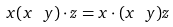<formula> <loc_0><loc_0><loc_500><loc_500>x ( x \ y ) \cdot z = x \cdot ( x \ y ) z</formula> 